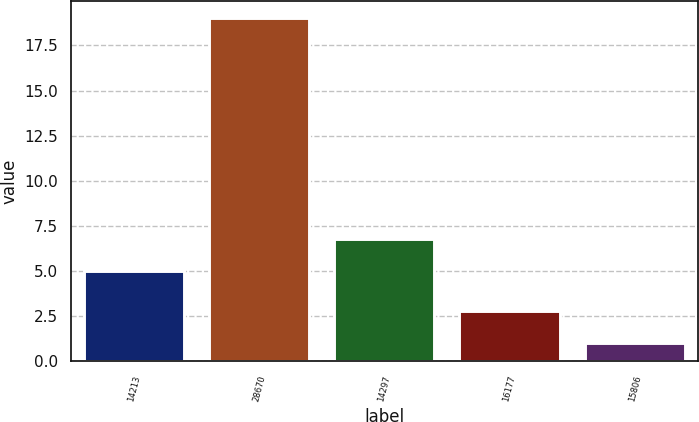Convert chart. <chart><loc_0><loc_0><loc_500><loc_500><bar_chart><fcel>14213<fcel>28670<fcel>14297<fcel>16177<fcel>15806<nl><fcel>5<fcel>19<fcel>6.8<fcel>2.8<fcel>1<nl></chart> 